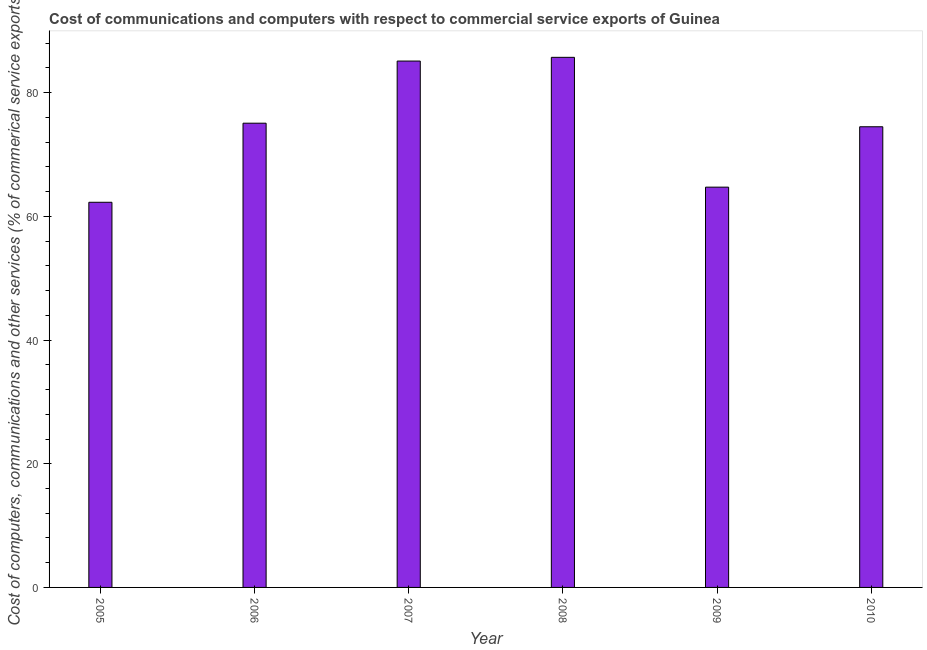What is the title of the graph?
Offer a very short reply. Cost of communications and computers with respect to commercial service exports of Guinea. What is the label or title of the X-axis?
Ensure brevity in your answer.  Year. What is the label or title of the Y-axis?
Keep it short and to the point. Cost of computers, communications and other services (% of commerical service exports). What is the cost of communications in 2008?
Ensure brevity in your answer.  85.72. Across all years, what is the maximum  computer and other services?
Your answer should be very brief. 85.72. Across all years, what is the minimum cost of communications?
Keep it short and to the point. 62.29. What is the sum of the  computer and other services?
Make the answer very short. 447.44. What is the difference between the  computer and other services in 2006 and 2007?
Your answer should be very brief. -10.05. What is the average cost of communications per year?
Provide a succinct answer. 74.57. What is the median  computer and other services?
Offer a terse response. 74.79. What is the ratio of the cost of communications in 2006 to that in 2007?
Keep it short and to the point. 0.88. What is the difference between the highest and the second highest  computer and other services?
Your answer should be very brief. 0.6. Is the sum of the cost of communications in 2005 and 2007 greater than the maximum cost of communications across all years?
Provide a short and direct response. Yes. What is the difference between the highest and the lowest  computer and other services?
Give a very brief answer. 23.44. In how many years, is the cost of communications greater than the average cost of communications taken over all years?
Offer a very short reply. 3. How many bars are there?
Give a very brief answer. 6. Are all the bars in the graph horizontal?
Provide a short and direct response. No. What is the difference between two consecutive major ticks on the Y-axis?
Provide a succinct answer. 20. Are the values on the major ticks of Y-axis written in scientific E-notation?
Offer a very short reply. No. What is the Cost of computers, communications and other services (% of commerical service exports) in 2005?
Make the answer very short. 62.29. What is the Cost of computers, communications and other services (% of commerical service exports) in 2006?
Ensure brevity in your answer.  75.07. What is the Cost of computers, communications and other services (% of commerical service exports) in 2007?
Keep it short and to the point. 85.12. What is the Cost of computers, communications and other services (% of commerical service exports) of 2008?
Your response must be concise. 85.72. What is the Cost of computers, communications and other services (% of commerical service exports) in 2009?
Your answer should be very brief. 64.73. What is the Cost of computers, communications and other services (% of commerical service exports) in 2010?
Provide a succinct answer. 74.5. What is the difference between the Cost of computers, communications and other services (% of commerical service exports) in 2005 and 2006?
Give a very brief answer. -12.79. What is the difference between the Cost of computers, communications and other services (% of commerical service exports) in 2005 and 2007?
Give a very brief answer. -22.84. What is the difference between the Cost of computers, communications and other services (% of commerical service exports) in 2005 and 2008?
Keep it short and to the point. -23.44. What is the difference between the Cost of computers, communications and other services (% of commerical service exports) in 2005 and 2009?
Offer a very short reply. -2.45. What is the difference between the Cost of computers, communications and other services (% of commerical service exports) in 2005 and 2010?
Offer a very short reply. -12.21. What is the difference between the Cost of computers, communications and other services (% of commerical service exports) in 2006 and 2007?
Give a very brief answer. -10.05. What is the difference between the Cost of computers, communications and other services (% of commerical service exports) in 2006 and 2008?
Give a very brief answer. -10.65. What is the difference between the Cost of computers, communications and other services (% of commerical service exports) in 2006 and 2009?
Your answer should be compact. 10.34. What is the difference between the Cost of computers, communications and other services (% of commerical service exports) in 2006 and 2010?
Your answer should be compact. 0.57. What is the difference between the Cost of computers, communications and other services (% of commerical service exports) in 2007 and 2008?
Your response must be concise. -0.6. What is the difference between the Cost of computers, communications and other services (% of commerical service exports) in 2007 and 2009?
Provide a succinct answer. 20.39. What is the difference between the Cost of computers, communications and other services (% of commerical service exports) in 2007 and 2010?
Make the answer very short. 10.62. What is the difference between the Cost of computers, communications and other services (% of commerical service exports) in 2008 and 2009?
Ensure brevity in your answer.  20.99. What is the difference between the Cost of computers, communications and other services (% of commerical service exports) in 2008 and 2010?
Offer a very short reply. 11.23. What is the difference between the Cost of computers, communications and other services (% of commerical service exports) in 2009 and 2010?
Provide a succinct answer. -9.77. What is the ratio of the Cost of computers, communications and other services (% of commerical service exports) in 2005 to that in 2006?
Offer a terse response. 0.83. What is the ratio of the Cost of computers, communications and other services (% of commerical service exports) in 2005 to that in 2007?
Provide a short and direct response. 0.73. What is the ratio of the Cost of computers, communications and other services (% of commerical service exports) in 2005 to that in 2008?
Offer a very short reply. 0.73. What is the ratio of the Cost of computers, communications and other services (% of commerical service exports) in 2005 to that in 2009?
Provide a short and direct response. 0.96. What is the ratio of the Cost of computers, communications and other services (% of commerical service exports) in 2005 to that in 2010?
Provide a succinct answer. 0.84. What is the ratio of the Cost of computers, communications and other services (% of commerical service exports) in 2006 to that in 2007?
Offer a terse response. 0.88. What is the ratio of the Cost of computers, communications and other services (% of commerical service exports) in 2006 to that in 2008?
Provide a succinct answer. 0.88. What is the ratio of the Cost of computers, communications and other services (% of commerical service exports) in 2006 to that in 2009?
Provide a short and direct response. 1.16. What is the ratio of the Cost of computers, communications and other services (% of commerical service exports) in 2006 to that in 2010?
Give a very brief answer. 1.01. What is the ratio of the Cost of computers, communications and other services (% of commerical service exports) in 2007 to that in 2009?
Provide a short and direct response. 1.31. What is the ratio of the Cost of computers, communications and other services (% of commerical service exports) in 2007 to that in 2010?
Provide a succinct answer. 1.14. What is the ratio of the Cost of computers, communications and other services (% of commerical service exports) in 2008 to that in 2009?
Provide a short and direct response. 1.32. What is the ratio of the Cost of computers, communications and other services (% of commerical service exports) in 2008 to that in 2010?
Ensure brevity in your answer.  1.15. What is the ratio of the Cost of computers, communications and other services (% of commerical service exports) in 2009 to that in 2010?
Keep it short and to the point. 0.87. 